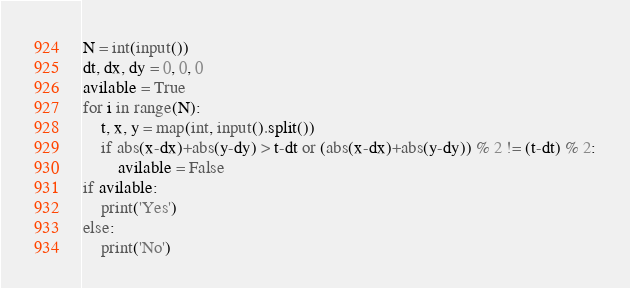<code> <loc_0><loc_0><loc_500><loc_500><_Python_>N = int(input())
dt, dx, dy = 0, 0, 0
avilable = True
for i in range(N):
    t, x, y = map(int, input().split())
    if abs(x-dx)+abs(y-dy) > t-dt or (abs(x-dx)+abs(y-dy)) % 2 != (t-dt) % 2:
        avilable = False
if avilable:
    print('Yes')
else:
    print('No')
</code> 